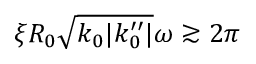Convert formula to latex. <formula><loc_0><loc_0><loc_500><loc_500>\xi R _ { 0 } \sqrt { k _ { 0 } | k _ { 0 } ^ { \prime \prime } | } \omega \gtrsim 2 \pi</formula> 